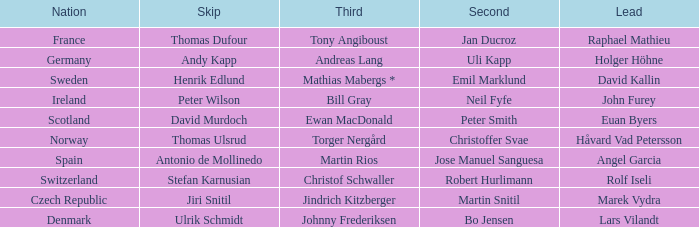Which Third has a Nation of scotland? Ewan MacDonald. 